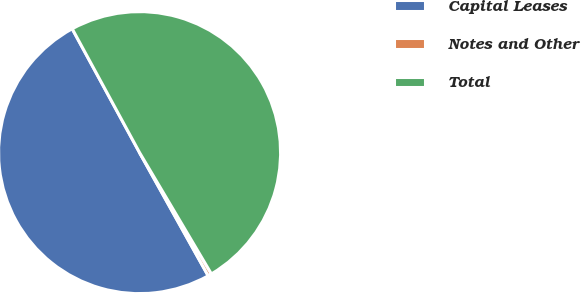<chart> <loc_0><loc_0><loc_500><loc_500><pie_chart><fcel>Capital Leases<fcel>Notes and Other<fcel>Total<nl><fcel>50.16%<fcel>0.42%<fcel>49.42%<nl></chart> 